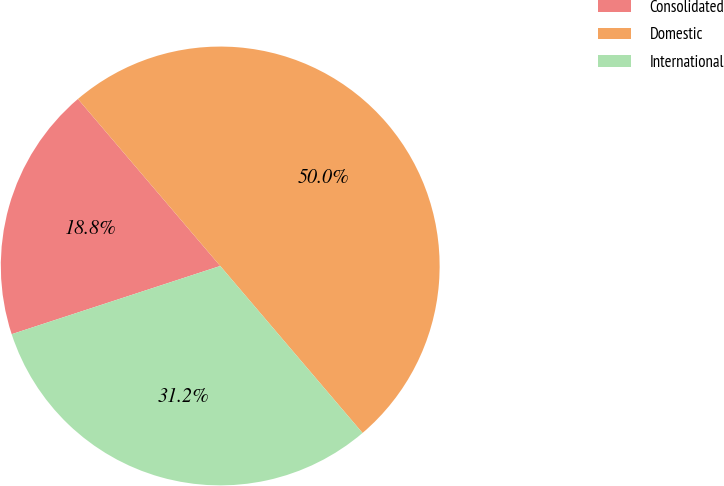Convert chart. <chart><loc_0><loc_0><loc_500><loc_500><pie_chart><fcel>Consolidated<fcel>Domestic<fcel>International<nl><fcel>18.8%<fcel>50.0%<fcel>31.2%<nl></chart> 